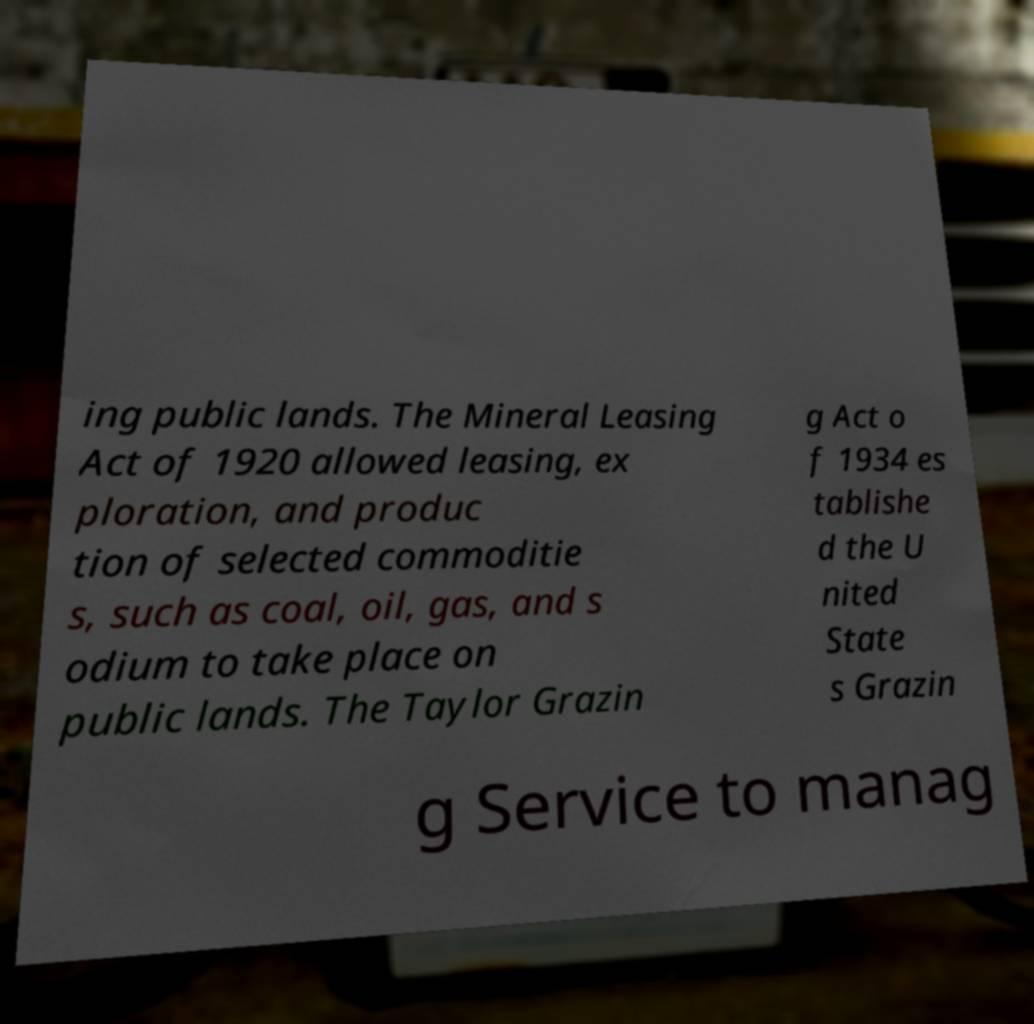What messages or text are displayed in this image? I need them in a readable, typed format. ing public lands. The Mineral Leasing Act of 1920 allowed leasing, ex ploration, and produc tion of selected commoditie s, such as coal, oil, gas, and s odium to take place on public lands. The Taylor Grazin g Act o f 1934 es tablishe d the U nited State s Grazin g Service to manag 